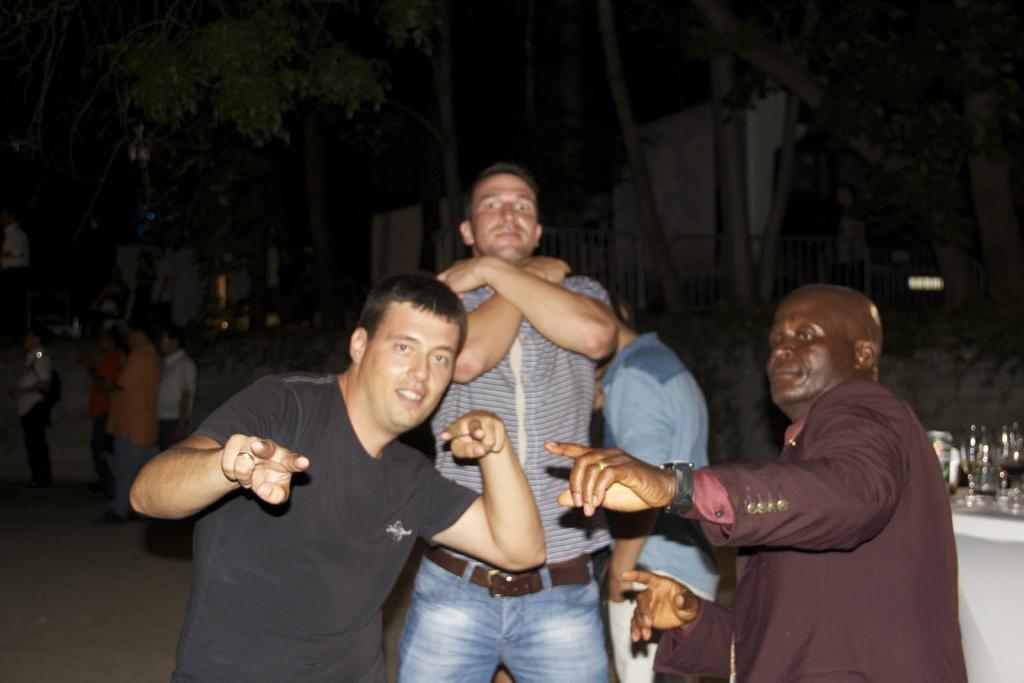How would you summarize this image in a sentence or two? This image consists of some persons. In front there are some persons who are standing. There are trees at the top. There is a table on the right side. On that there are bottles and glasses. 